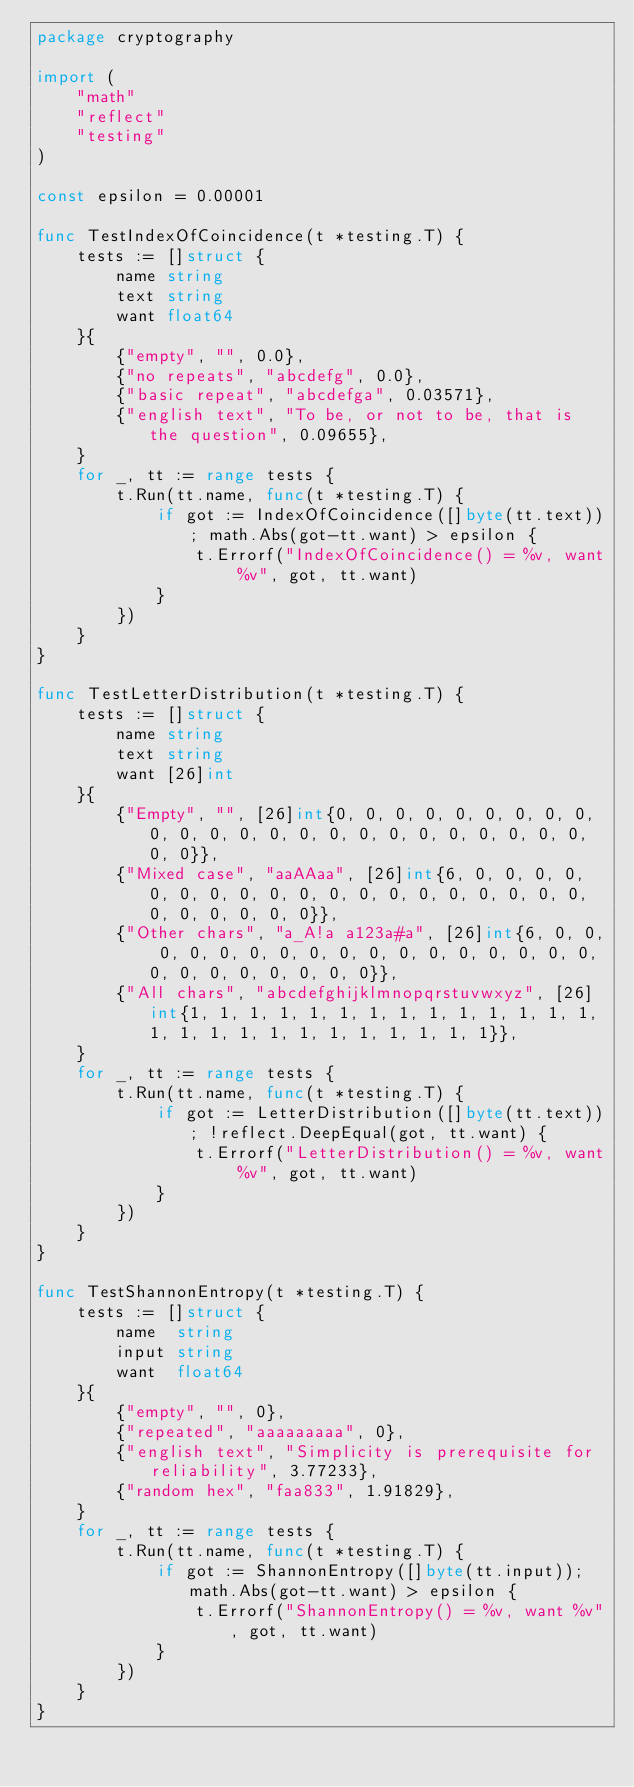<code> <loc_0><loc_0><loc_500><loc_500><_Go_>package cryptography

import (
	"math"
	"reflect"
	"testing"
)

const epsilon = 0.00001

func TestIndexOfCoincidence(t *testing.T) {
	tests := []struct {
		name string
		text string
		want float64
	}{
		{"empty", "", 0.0},
		{"no repeats", "abcdefg", 0.0},
		{"basic repeat", "abcdefga", 0.03571},
		{"english text", "To be, or not to be, that is the question", 0.09655},
	}
	for _, tt := range tests {
		t.Run(tt.name, func(t *testing.T) {
			if got := IndexOfCoincidence([]byte(tt.text)); math.Abs(got-tt.want) > epsilon {
				t.Errorf("IndexOfCoincidence() = %v, want %v", got, tt.want)
			}
		})
	}
}

func TestLetterDistribution(t *testing.T) {
	tests := []struct {
		name string
		text string
		want [26]int
	}{
		{"Empty", "", [26]int{0, 0, 0, 0, 0, 0, 0, 0, 0, 0, 0, 0, 0, 0, 0, 0, 0, 0, 0, 0, 0, 0, 0, 0, 0, 0}},
		{"Mixed case", "aaAAaa", [26]int{6, 0, 0, 0, 0, 0, 0, 0, 0, 0, 0, 0, 0, 0, 0, 0, 0, 0, 0, 0, 0, 0, 0, 0, 0, 0}},
		{"Other chars", "a_A!a a123a#a", [26]int{6, 0, 0, 0, 0, 0, 0, 0, 0, 0, 0, 0, 0, 0, 0, 0, 0, 0, 0, 0, 0, 0, 0, 0, 0, 0}},
		{"All chars", "abcdefghijklmnopqrstuvwxyz", [26]int{1, 1, 1, 1, 1, 1, 1, 1, 1, 1, 1, 1, 1, 1, 1, 1, 1, 1, 1, 1, 1, 1, 1, 1, 1, 1}},
	}
	for _, tt := range tests {
		t.Run(tt.name, func(t *testing.T) {
			if got := LetterDistribution([]byte(tt.text)); !reflect.DeepEqual(got, tt.want) {
				t.Errorf("LetterDistribution() = %v, want %v", got, tt.want)
			}
		})
	}
}

func TestShannonEntropy(t *testing.T) {
	tests := []struct {
		name  string
		input string
		want  float64
	}{
		{"empty", "", 0},
		{"repeated", "aaaaaaaaa", 0},
		{"english text", "Simplicity is prerequisite for reliability", 3.77233},
		{"random hex", "faa833", 1.91829},
	}
	for _, tt := range tests {
		t.Run(tt.name, func(t *testing.T) {
			if got := ShannonEntropy([]byte(tt.input)); math.Abs(got-tt.want) > epsilon {
				t.Errorf("ShannonEntropy() = %v, want %v", got, tt.want)
			}
		})
	}
}
</code> 